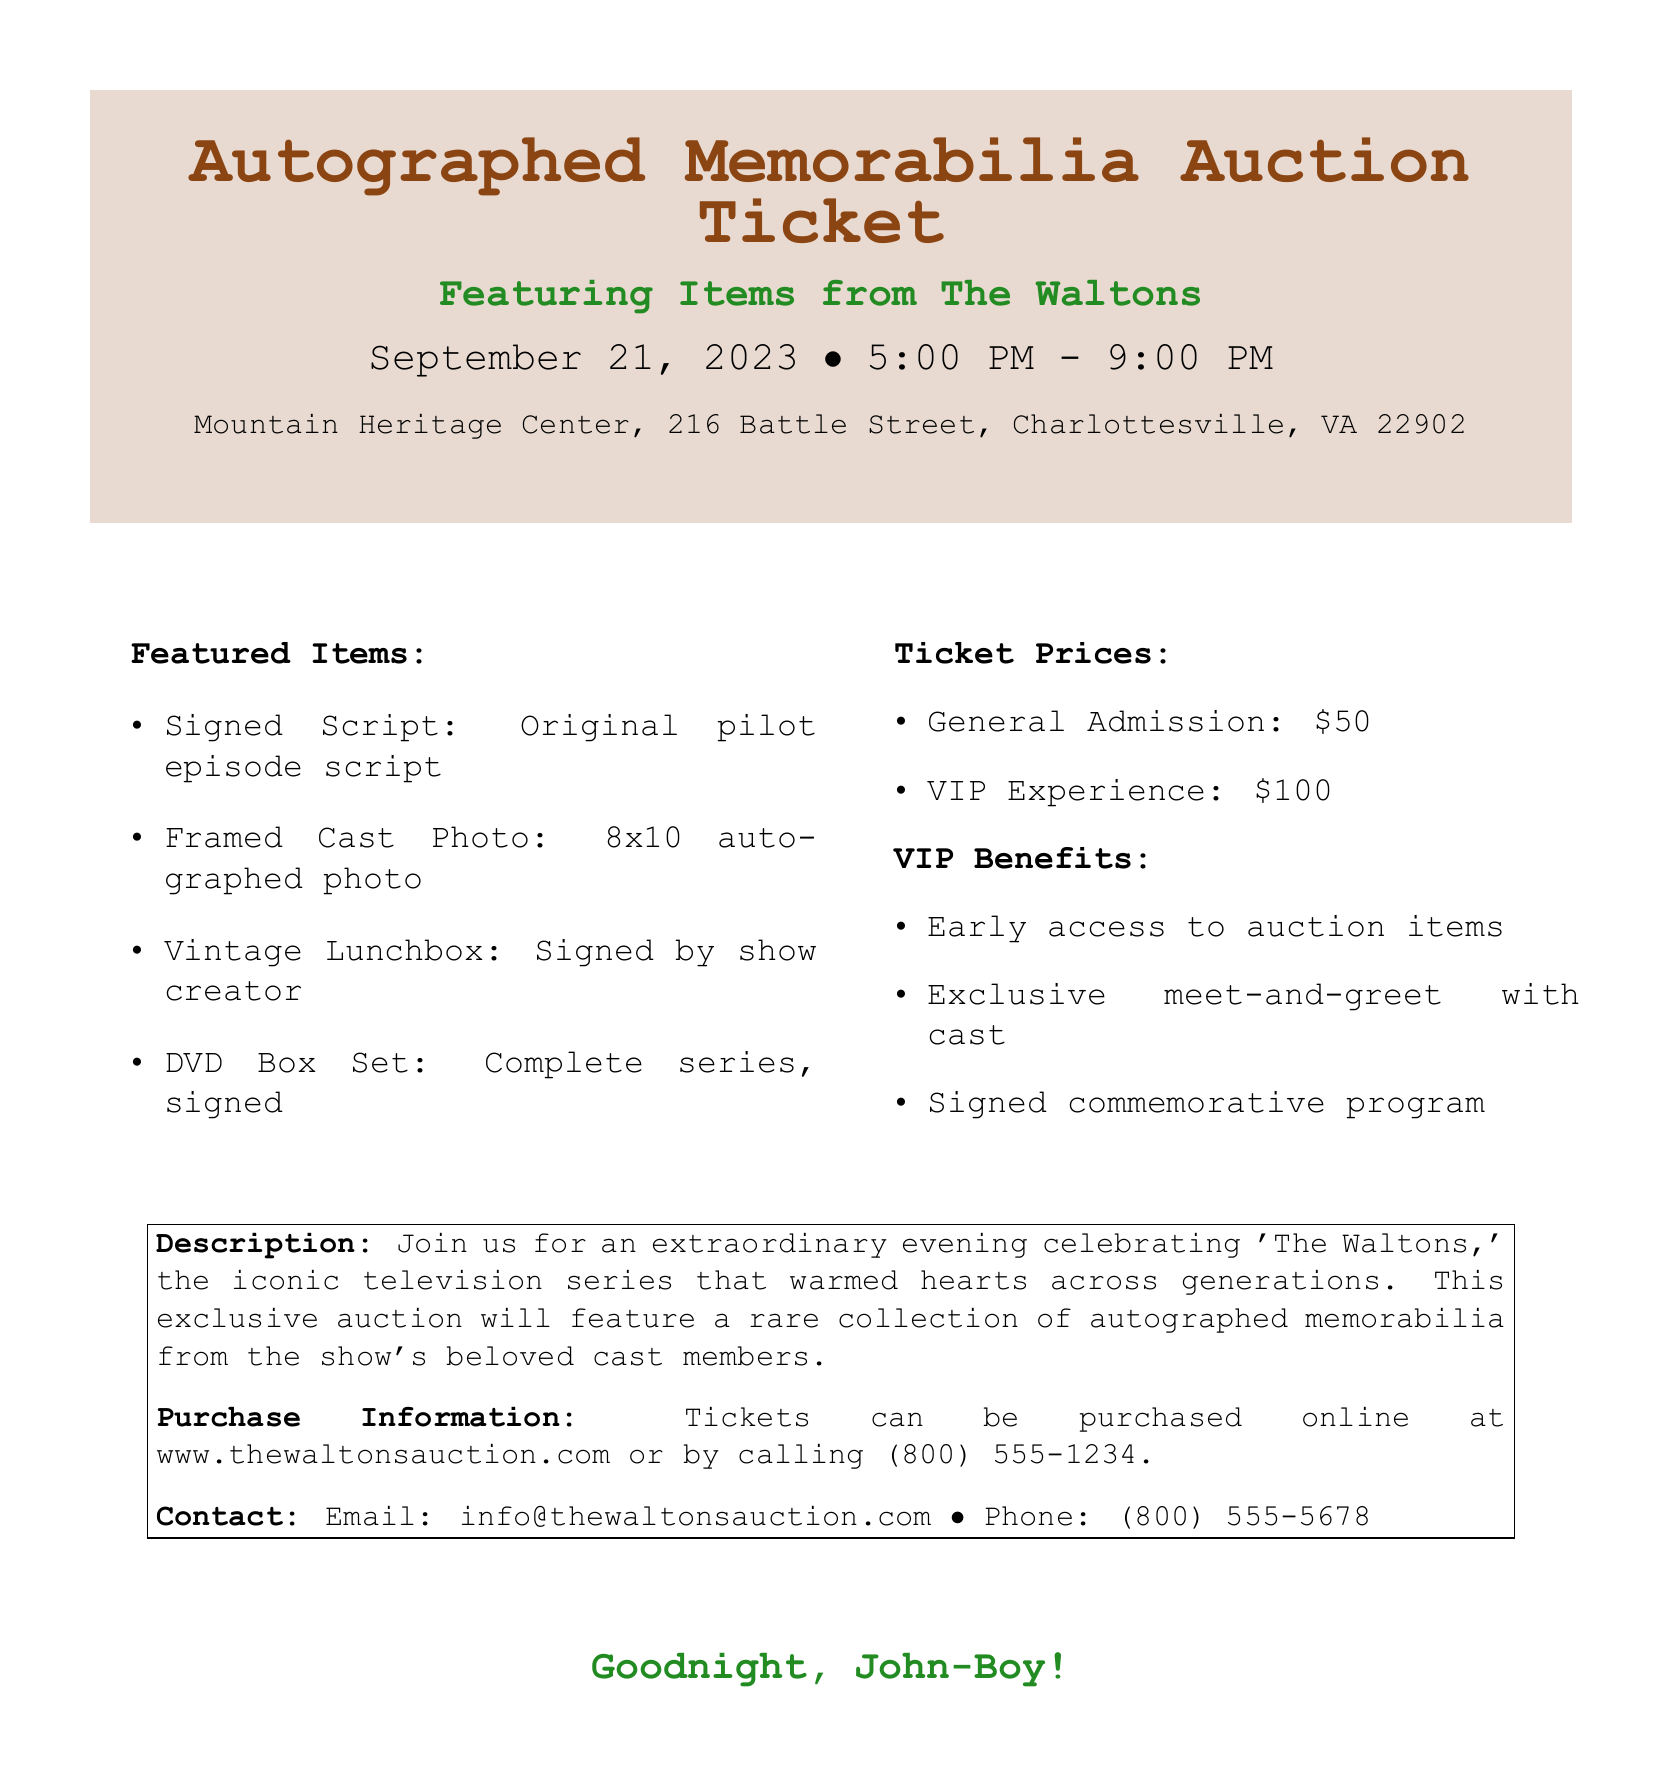What is the name of the auction event? The event is specifically named "Autographed Memorabilia Auction."
Answer: Autographed Memorabilia Auction When is the auction taking place? The auction is scheduled for September 21, 2023.
Answer: September 21, 2023 What is the location of the auction? The auction will be held at Mountain Heritage Center, 216 Battle Street, Charlottesville, VA 22902.
Answer: Mountain Heritage Center, 216 Battle Street, Charlottesville, VA 22902 What are the prices for general admission tickets? The document lists the general admission ticket price as $50.
Answer: $50 What is included in the VIP experience? The VIP experience includes early access to auction items and exclusive meet-and-greet with cast.
Answer: Early access to auction items How many items are featured in the auction? The document lists four featured items from the auction.
Answer: Four Who created the vintage lunchbox item listed? The vintage lunchbox is signed by the show creator.
Answer: show creator What is one benefit of purchasing a VIP ticket? One benefit of the VIP ticket is a signed commemorative program.
Answer: signed commemorative program What is the contact email provided in the document? The email for contact is info@thewaltonsauction.com.
Answer: info@thewaltonsauction.com 